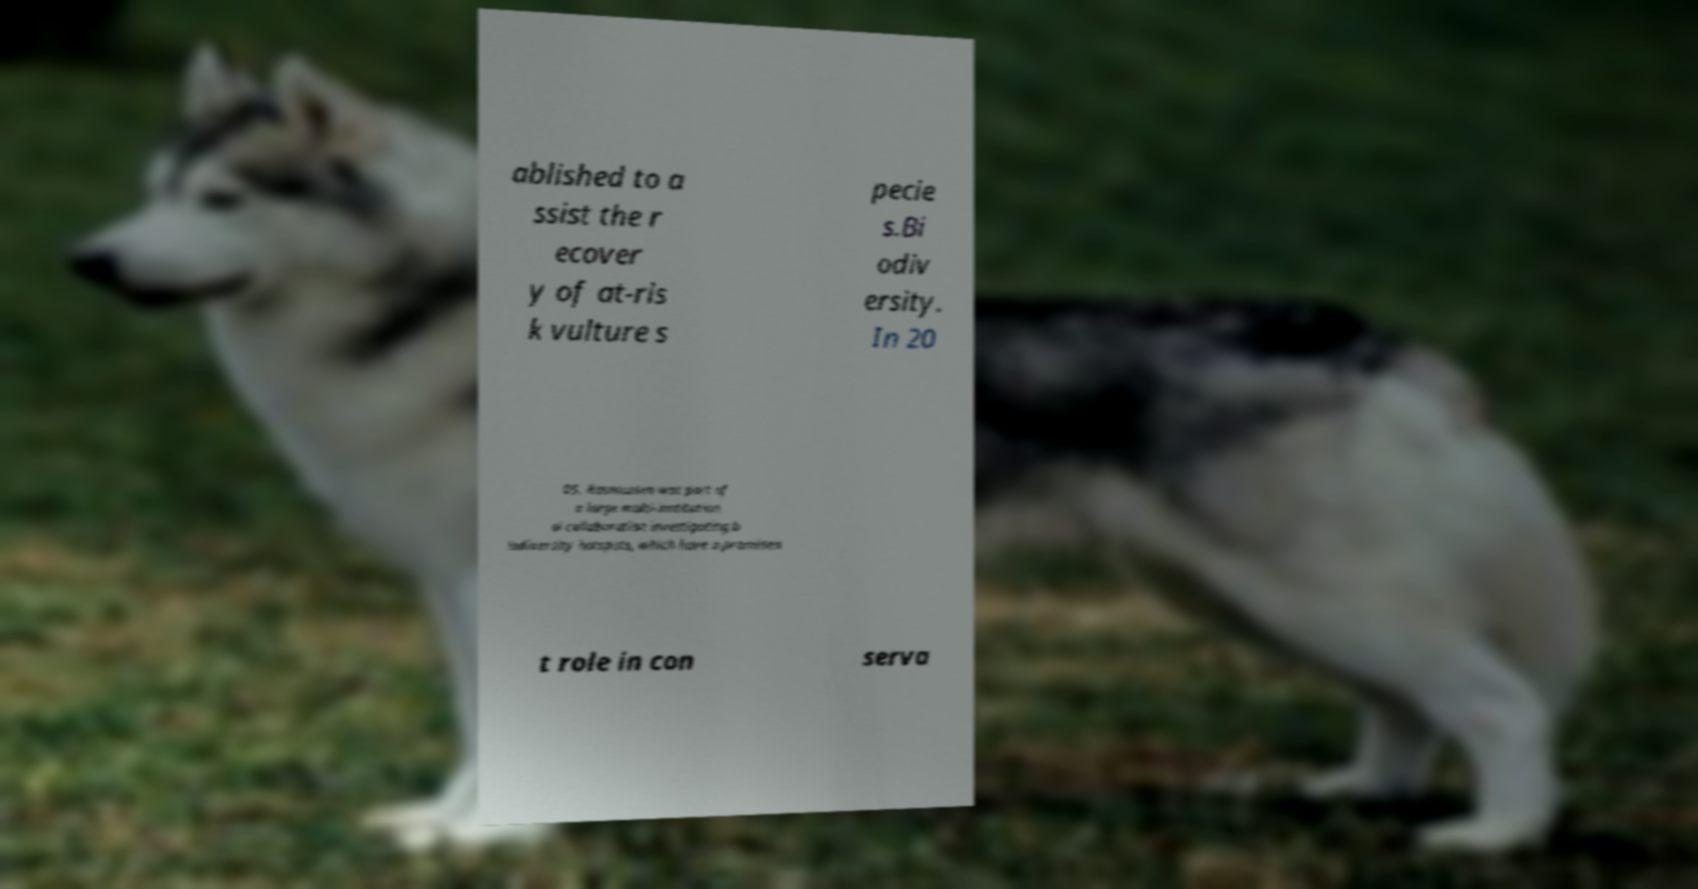Please read and relay the text visible in this image. What does it say? ablished to a ssist the r ecover y of at-ris k vulture s pecie s.Bi odiv ersity. In 20 05, Rasmussen was part of a large multi-institution al collaboration investigating b iodiversity hotspots, which have a prominen t role in con serva 